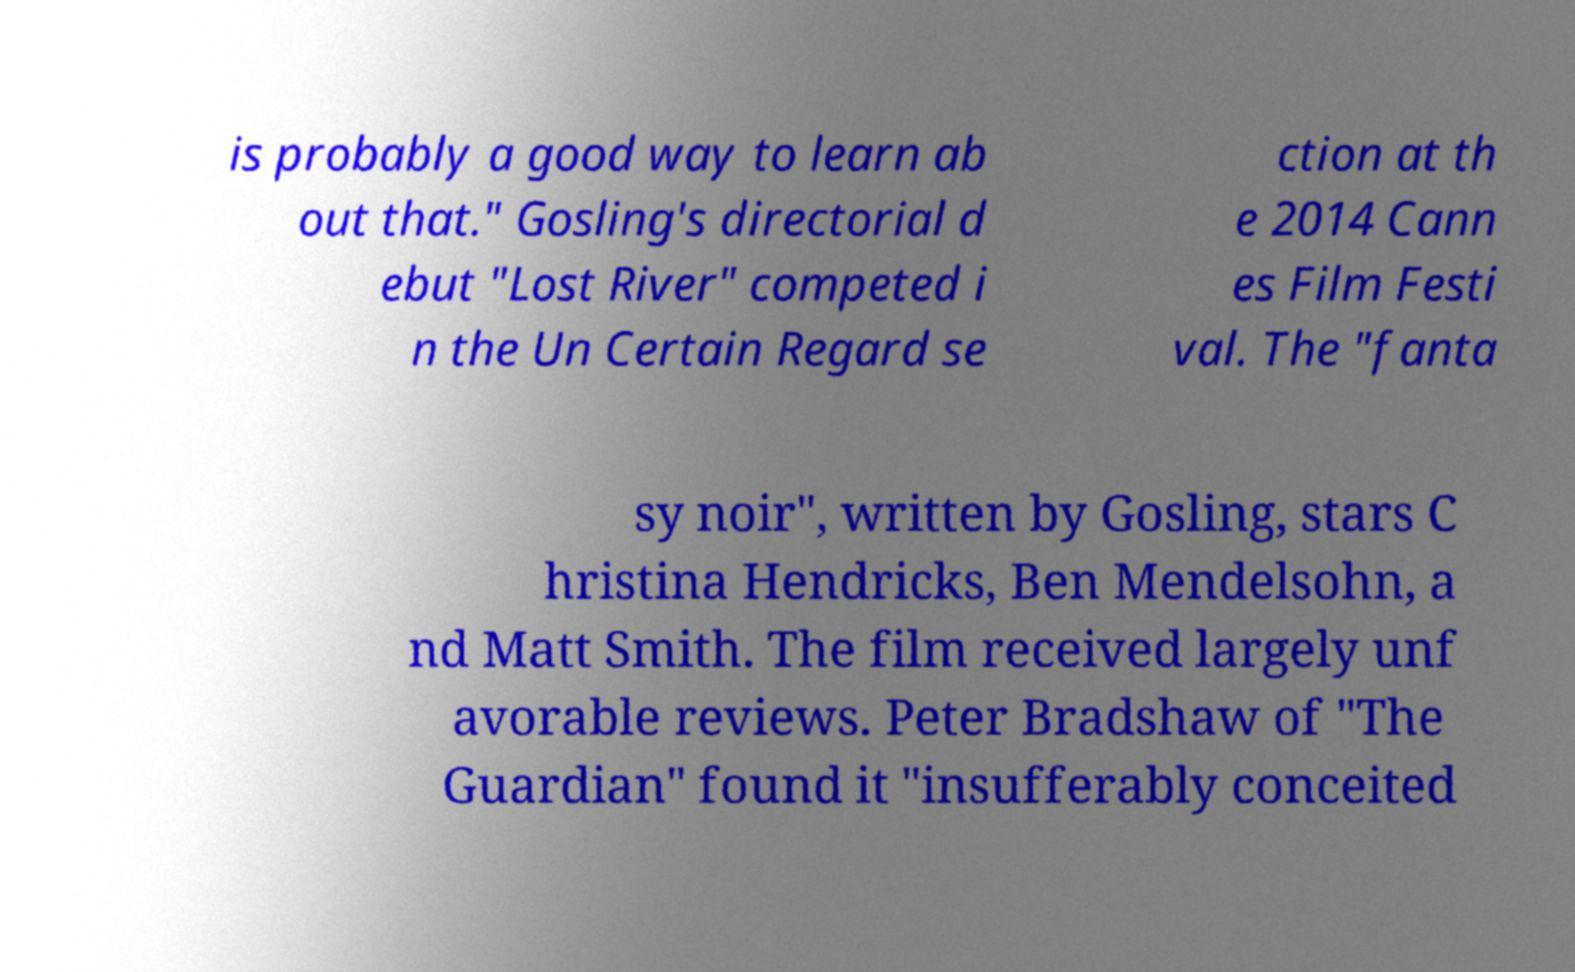For documentation purposes, I need the text within this image transcribed. Could you provide that? is probably a good way to learn ab out that." Gosling's directorial d ebut "Lost River" competed i n the Un Certain Regard se ction at th e 2014 Cann es Film Festi val. The "fanta sy noir", written by Gosling, stars C hristina Hendricks, Ben Mendelsohn, a nd Matt Smith. The film received largely unf avorable reviews. Peter Bradshaw of "The Guardian" found it "insufferably conceited 